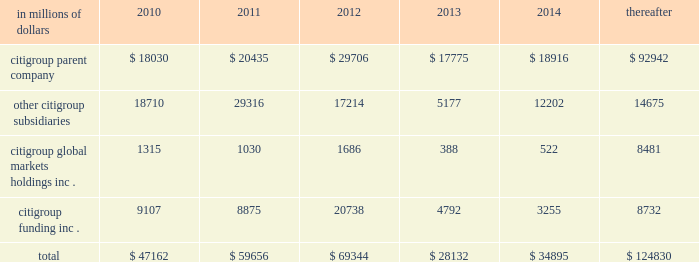Cgmhi also has substantial borrowing arrangements consisting of facilities that cgmhi has been advised are available , but where no contractual lending obligation exists .
These arrangements are reviewed on an ongoing basis to ensure flexibility in meeting cgmhi 2019s short-term requirements .
The company issues both fixed and variable rate debt in a range of currencies .
It uses derivative contracts , primarily interest rate swaps , to effectively convert a portion of its fixed rate debt to variable rate debt and variable rate debt to fixed rate debt .
The maturity structure of the derivatives generally corresponds to the maturity structure of the debt being hedged .
In addition , the company uses other derivative contracts to manage the foreign exchange impact of certain debt issuances .
At december 31 , 2009 , the company 2019s overall weighted average interest rate for long-term debt was 3.51% ( 3.51 % ) on a contractual basis and 3.91% ( 3.91 % ) including the effects of derivative contracts .
Aggregate annual maturities of long-term debt obligations ( based on final maturity dates ) including trust preferred securities are as follows: .
Long-term debt at december 31 , 2009 and december 31 , 2008 includes $ 19345 million and $ 24060 million , respectively , of junior subordinated debt .
The company formed statutory business trusts under the laws of the state of delaware .
The trusts exist for the exclusive purposes of ( i ) issuing trust securities representing undivided beneficial interests in the assets of the trust ; ( ii ) investing the gross proceeds of the trust securities in junior subordinated deferrable interest debentures ( subordinated debentures ) of its parent ; and ( iii ) engaging in only those activities necessary or incidental thereto .
Upon approval from the federal reserve , citigroup has the right to redeem these securities .
Citigroup has contractually agreed not to redeem or purchase ( i ) the 6.50% ( 6.50 % ) enhanced trust preferred securities of citigroup capital xv before september 15 , 2056 , ( ii ) the 6.45% ( 6.45 % ) enhanced trust preferred securities of citigroup capital xvi before december 31 , 2046 , ( iii ) the 6.35% ( 6.35 % ) enhanced trust preferred securities of citigroup capital xvii before march 15 , 2057 , ( iv ) the 6.829% ( 6.829 % ) fixed rate/floating rate enhanced trust preferred securities of citigroup capital xviii before june 28 , 2047 , ( v ) the 7.250% ( 7.250 % ) enhanced trust preferred securities of citigroup capital xix before august 15 , 2047 , ( vi ) the 7.875% ( 7.875 % ) enhanced trust preferred securities of citigroup capital xx before december 15 , 2067 , and ( vii ) the 8.300% ( 8.300 % ) fixed rate/floating rate enhanced trust preferred securities of citigroup capital xxi before december 21 , 2067 , unless certain conditions , described in exhibit 4.03 to citigroup 2019s current report on form 8-k filed on september 18 , 2006 , in exhibit 4.02 to citigroup 2019s current report on form 8-k filed on november 28 , 2006 , in exhibit 4.02 to citigroup 2019s current report on form 8-k filed on march 8 , 2007 , in exhibit 4.02 to citigroup 2019s current report on form 8-k filed on july 2 , 2007 , in exhibit 4.02 to citigroup 2019s current report on form 8-k filed on august 17 , 2007 , in exhibit 4.2 to citigroup 2019s current report on form 8-k filed on november 27 , 2007 , and in exhibit 4.2 to citigroup 2019s current report on form 8-k filed on december 21 , 2007 , respectively , are met .
These agreements are for the benefit of the holders of citigroup 2019s 6.00% ( 6.00 % ) junior subordinated deferrable interest debentures due 2034 .
Citigroup owns all of the voting securities of these subsidiary trusts .
These subsidiary trusts have no assets , operations , revenues or cash flows other than those related to the issuance , administration , and repayment of the subsidiary trusts and the subsidiary trusts 2019 common securities .
These subsidiary trusts 2019 obligations are fully and unconditionally guaranteed by citigroup. .
What was the percent of the change in the aggregate annual maturities of long-term debt obligations for the citigroup parent company from 2010 to 2011? 
Rationale: the aggregate annual maturities of long-term debt obligations for the citigroup parent company increased by 13.3% from 2010 to 2011
Computations: ((20435 - 18030) / 18030)
Answer: 0.13339. 